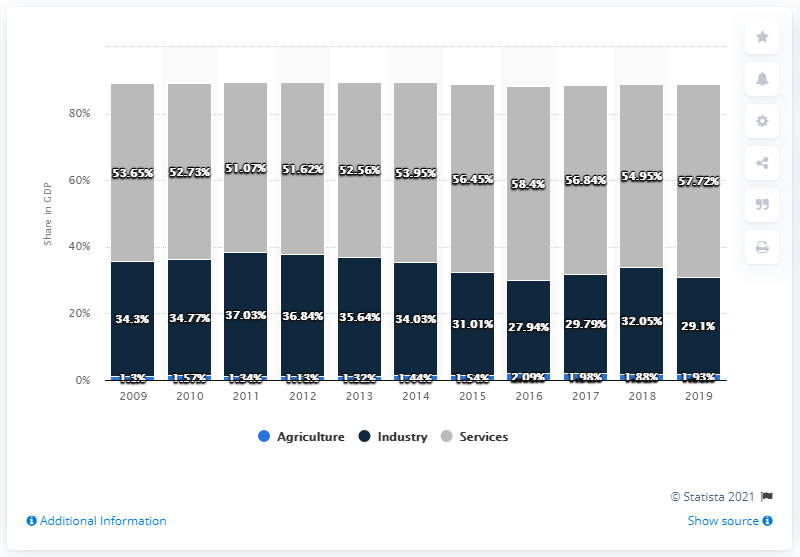Draw attention to some important aspects in this diagram. In 2019, agriculture accounted for 1.93% of Norway's gross domestic product. 